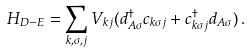Convert formula to latex. <formula><loc_0><loc_0><loc_500><loc_500>H _ { D - E } = \sum _ { k , \sigma , j } V _ { k j } ( d ^ { \dag } _ { A \sigma } c _ { k \sigma j } + c ^ { \dag } _ { k \sigma j } d _ { A \sigma } ) \, .</formula> 